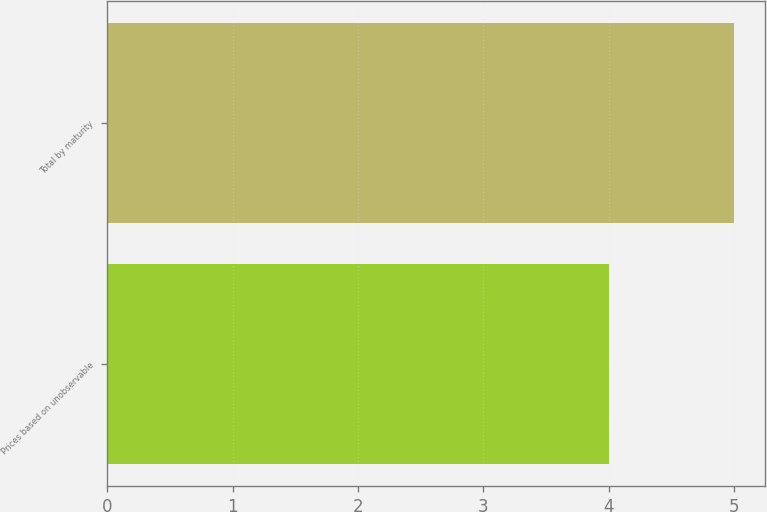Convert chart to OTSL. <chart><loc_0><loc_0><loc_500><loc_500><bar_chart><fcel>Prices based on unobservable<fcel>Total by maturity<nl><fcel>4<fcel>5<nl></chart> 